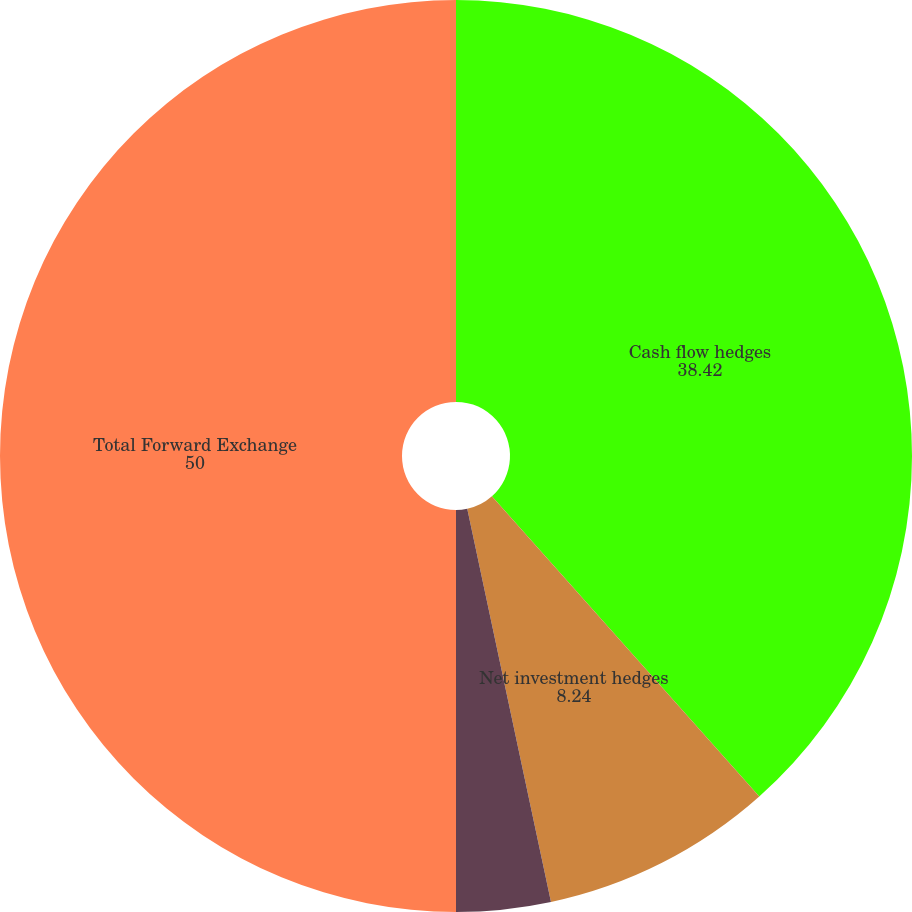Convert chart to OTSL. <chart><loc_0><loc_0><loc_500><loc_500><pie_chart><fcel>Cash flow hedges<fcel>Net investment hedges<fcel>Not designated<fcel>Total Forward Exchange<nl><fcel>38.42%<fcel>8.24%<fcel>3.34%<fcel>50.0%<nl></chart> 